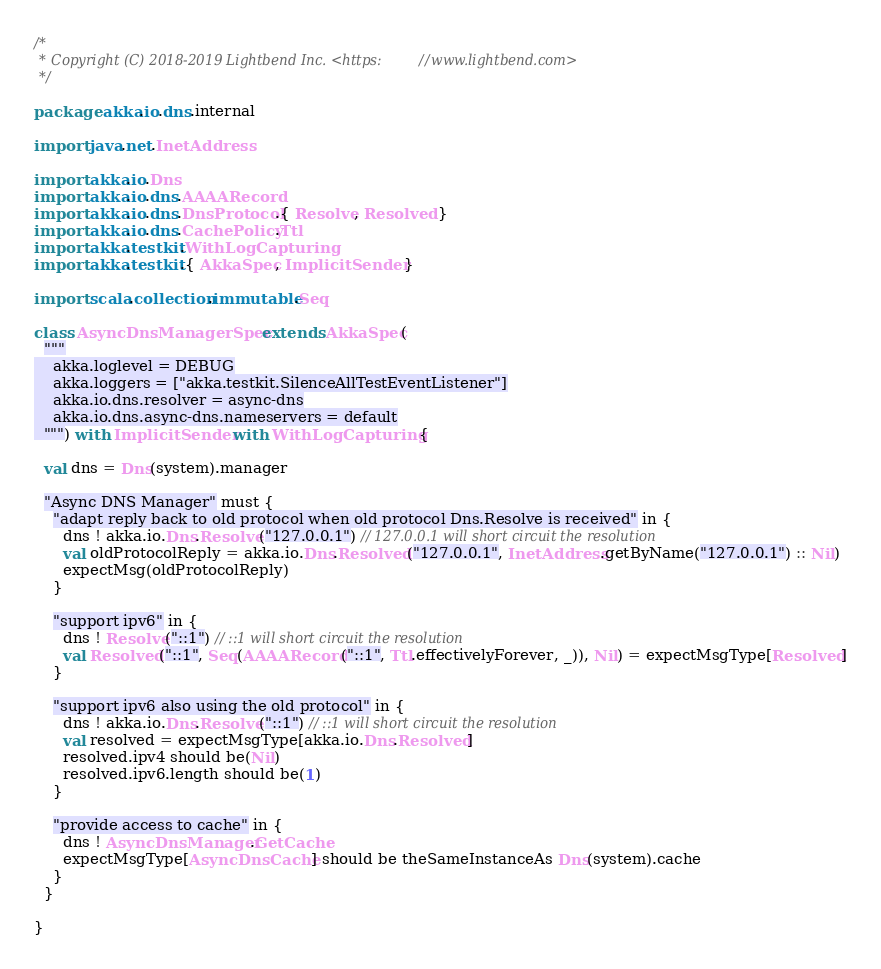<code> <loc_0><loc_0><loc_500><loc_500><_Scala_>/*
 * Copyright (C) 2018-2019 Lightbend Inc. <https://www.lightbend.com>
 */

package akka.io.dns.internal

import java.net.InetAddress

import akka.io.Dns
import akka.io.dns.AAAARecord
import akka.io.dns.DnsProtocol.{ Resolve, Resolved }
import akka.io.dns.CachePolicy.Ttl
import akka.testkit.WithLogCapturing
import akka.testkit.{ AkkaSpec, ImplicitSender }

import scala.collection.immutable.Seq

class AsyncDnsManagerSpec extends AkkaSpec(
  """
    akka.loglevel = DEBUG
    akka.loggers = ["akka.testkit.SilenceAllTestEventListener"]
    akka.io.dns.resolver = async-dns
    akka.io.dns.async-dns.nameservers = default
  """) with ImplicitSender with WithLogCapturing {

  val dns = Dns(system).manager

  "Async DNS Manager" must {
    "adapt reply back to old protocol when old protocol Dns.Resolve is received" in {
      dns ! akka.io.Dns.Resolve("127.0.0.1") // 127.0.0.1 will short circuit the resolution
      val oldProtocolReply = akka.io.Dns.Resolved("127.0.0.1", InetAddress.getByName("127.0.0.1") :: Nil)
      expectMsg(oldProtocolReply)
    }

    "support ipv6" in {
      dns ! Resolve("::1") // ::1 will short circuit the resolution
      val Resolved("::1", Seq(AAAARecord("::1", Ttl.effectivelyForever, _)), Nil) = expectMsgType[Resolved]
    }

    "support ipv6 also using the old protocol" in {
      dns ! akka.io.Dns.Resolve("::1") // ::1 will short circuit the resolution
      val resolved = expectMsgType[akka.io.Dns.Resolved]
      resolved.ipv4 should be(Nil)
      resolved.ipv6.length should be(1)
    }

    "provide access to cache" in {
      dns ! AsyncDnsManager.GetCache
      expectMsgType[AsyncDnsCache] should be theSameInstanceAs Dns(system).cache
    }
  }

}
</code> 